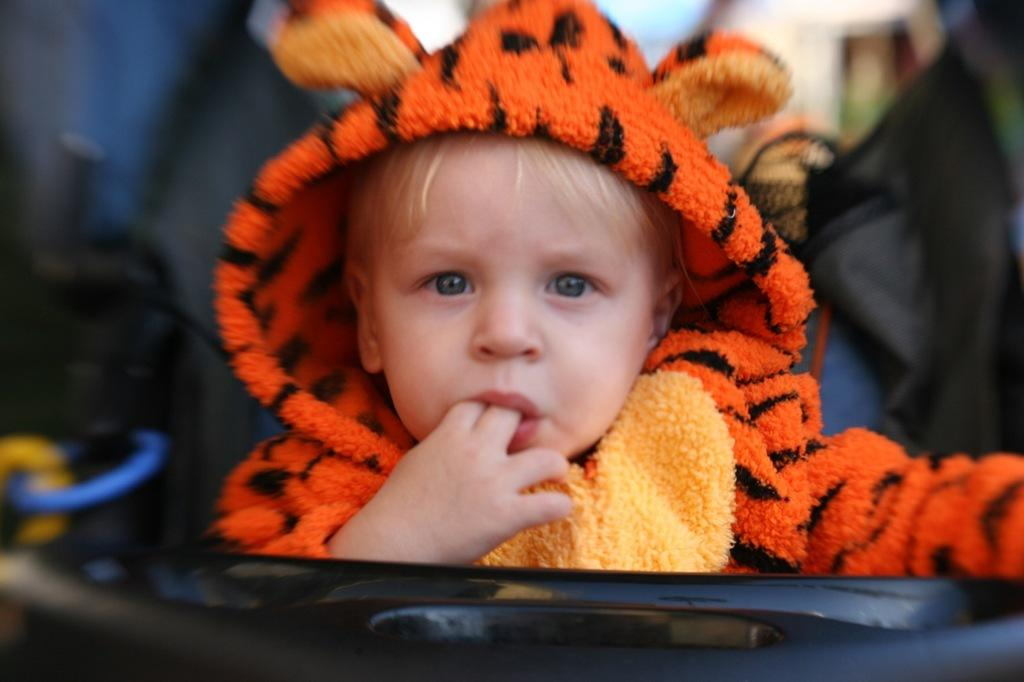What is the main subject of the image? The main subject of the image is a baby. What is the baby wearing in the image? The baby is wearing an orange dress. Can you describe the background of the image? The background of the image is blurred. Can you see a can of paint in the image? There is no can of paint present in the image. Is there a snail balancing on the baby's head in the image? There is no snail or any indication of balancing in the image; it features a baby wearing an orange dress with a blurred background. 